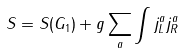<formula> <loc_0><loc_0><loc_500><loc_500>S = S ( G _ { 1 } ) + g \sum _ { a } \int j _ { L } ^ { a } j _ { R } ^ { a }</formula> 